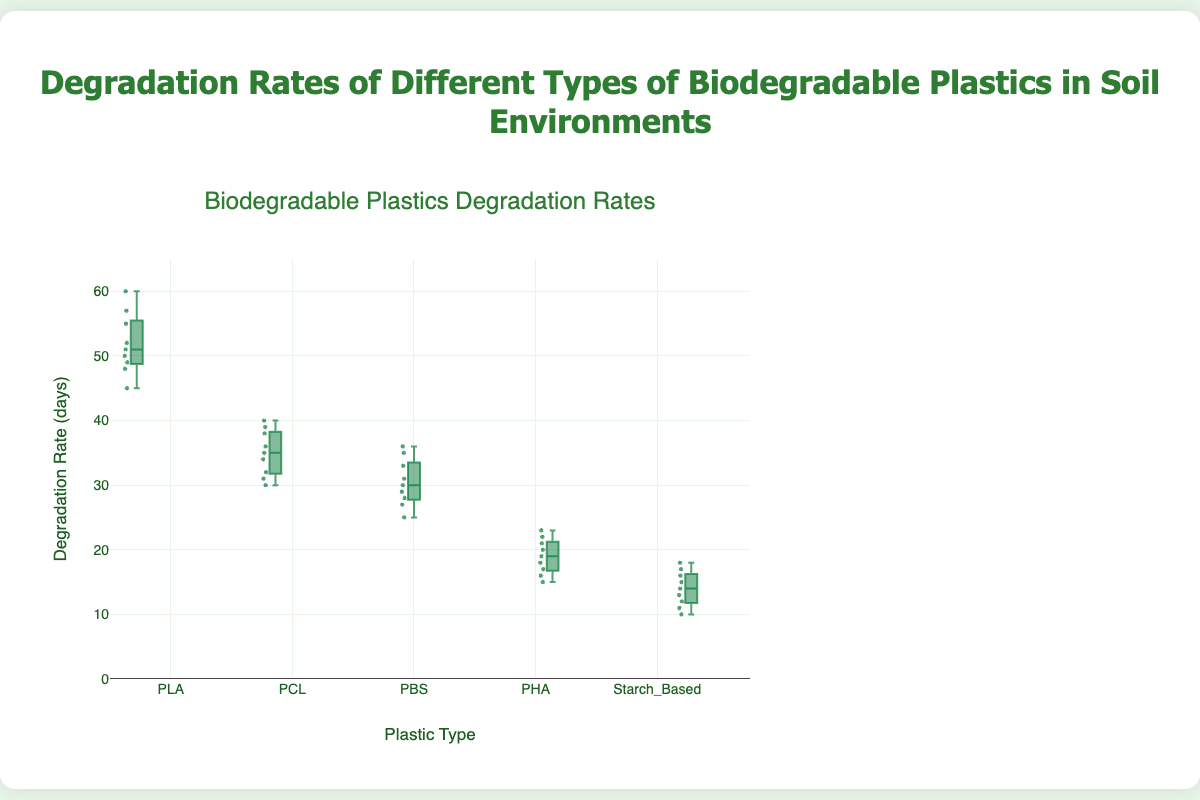Which plastic type has the highest median degradation rate? By looking at the box plot, we identify which box has the highest middle line representing the median. The middle line for PLA is the highest.
Answer: PLA What is the range of degradation rates for PHA? The range of a dataset in a box plot is the difference between the maximum and minimum values. For PHA, the minimum value is 15 and the maximum value is 23. So, the range is 23 - 15 = 8.
Answer: 8 How does the interquartile range (IQR) of PCL compare to Starch_Based? The IQR is the difference between the third quartile (Q3) and the first quartile (Q1). In the box plot, this is the length of the box. Visually, the box for PCL is larger than the box for Starch_Based, indicating a larger IQR for PCL.
Answer: PCL has a larger IQR than Starch_Based Which plastic type has the lowest minimum degradation rate? The minimum degradation rate is represented by the lowest point outside the whisker of the box plot. Starch_Based has the lowest minimum point at 10 days.
Answer: Starch_Based Compare the variation in degradation rates between PBS and PHA. To compare variation, observe the total spread of data points (whiskers and outliers). PBS has a wider spread compared to PHA. Thus, PBS shows greater variation in degradation rates.
Answer: PBS For which type of plastic is the upper quartile (75th percentile) closest to 40 days? The upper quartile is represented by the top of the box. For PCL, the upper quartile is closest to 40 days.
Answer: PCL Which two plastic types show overlapping interquartile ranges indicating similar middle 50% values? First, locate the boxes for all plastic types and see which of them overlap. PCL and PBS have interquartile ranges that overlap significantly.
Answer: PCL and PBS Is there any plastic type with an outlier in degradation rates? Outliers can be identified by points that fall outside the whiskers in the box plot. The box plot shows no points outside the whiskers for any types, indicating there are no outliers.
Answer: No What is the median degradation rate for PLA, and how does it compare to PCL? The median is the middle line in each box. The median for PLA is around 51, while for PCL it's about 35, indicating the PLA's median is higher.
Answer: PLA's median is higher than PCL's 